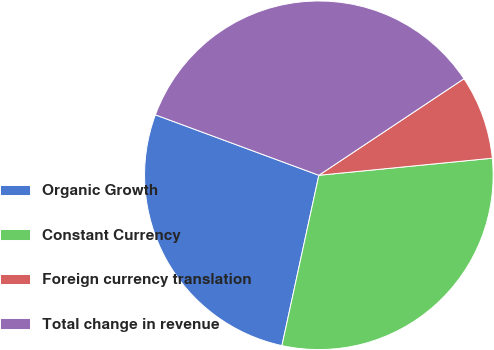Convert chart to OTSL. <chart><loc_0><loc_0><loc_500><loc_500><pie_chart><fcel>Organic Growth<fcel>Constant Currency<fcel>Foreign currency translation<fcel>Total change in revenue<nl><fcel>27.24%<fcel>29.96%<fcel>7.78%<fcel>35.02%<nl></chart> 